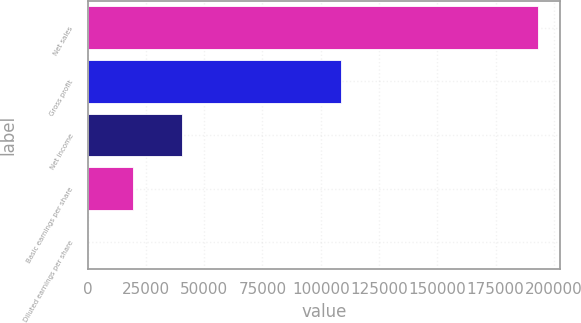Convert chart to OTSL. <chart><loc_0><loc_0><loc_500><loc_500><bar_chart><fcel>Net sales<fcel>Gross profit<fcel>Net income<fcel>Basic earnings per share<fcel>Diluted earnings per share<nl><fcel>193047<fcel>108811<fcel>40304<fcel>19305.4<fcel>0.8<nl></chart> 